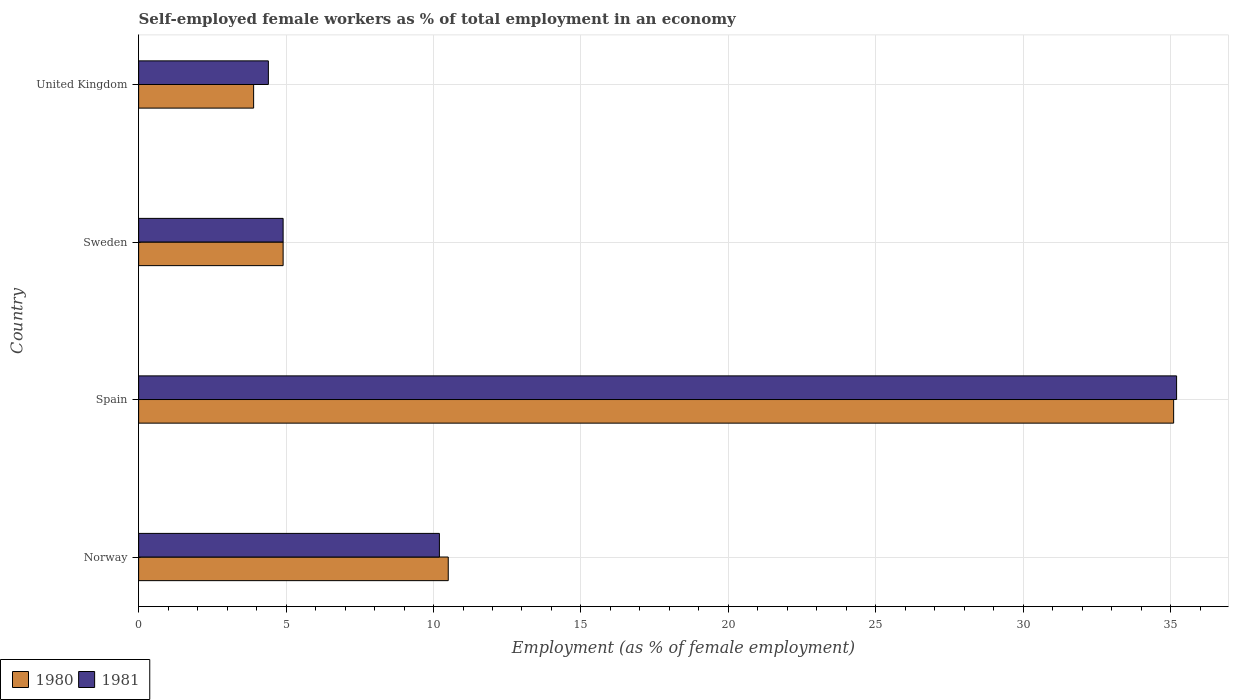How many different coloured bars are there?
Your answer should be compact. 2. How many groups of bars are there?
Ensure brevity in your answer.  4. How many bars are there on the 2nd tick from the top?
Provide a short and direct response. 2. What is the label of the 3rd group of bars from the top?
Offer a terse response. Spain. What is the percentage of self-employed female workers in 1981 in United Kingdom?
Keep it short and to the point. 4.4. Across all countries, what is the maximum percentage of self-employed female workers in 1981?
Offer a terse response. 35.2. Across all countries, what is the minimum percentage of self-employed female workers in 1981?
Offer a terse response. 4.4. In which country was the percentage of self-employed female workers in 1981 minimum?
Ensure brevity in your answer.  United Kingdom. What is the total percentage of self-employed female workers in 1981 in the graph?
Provide a short and direct response. 54.7. What is the difference between the percentage of self-employed female workers in 1980 in Norway and that in Spain?
Your answer should be compact. -24.6. What is the difference between the percentage of self-employed female workers in 1981 in United Kingdom and the percentage of self-employed female workers in 1980 in Norway?
Your answer should be compact. -6.1. What is the average percentage of self-employed female workers in 1981 per country?
Provide a short and direct response. 13.68. What is the difference between the percentage of self-employed female workers in 1980 and percentage of self-employed female workers in 1981 in Sweden?
Keep it short and to the point. 0. What is the ratio of the percentage of self-employed female workers in 1980 in Norway to that in Sweden?
Provide a short and direct response. 2.14. Is the percentage of self-employed female workers in 1980 in Norway less than that in Sweden?
Provide a succinct answer. No. What is the difference between the highest and the second highest percentage of self-employed female workers in 1980?
Provide a succinct answer. 24.6. What is the difference between the highest and the lowest percentage of self-employed female workers in 1980?
Provide a succinct answer. 31.2. How many bars are there?
Give a very brief answer. 8. Are all the bars in the graph horizontal?
Your response must be concise. Yes. How many countries are there in the graph?
Offer a very short reply. 4. What is the difference between two consecutive major ticks on the X-axis?
Offer a terse response. 5. Does the graph contain any zero values?
Offer a terse response. No. How are the legend labels stacked?
Provide a short and direct response. Horizontal. What is the title of the graph?
Make the answer very short. Self-employed female workers as % of total employment in an economy. Does "2002" appear as one of the legend labels in the graph?
Your answer should be compact. No. What is the label or title of the X-axis?
Offer a terse response. Employment (as % of female employment). What is the label or title of the Y-axis?
Your answer should be very brief. Country. What is the Employment (as % of female employment) in 1981 in Norway?
Your answer should be very brief. 10.2. What is the Employment (as % of female employment) in 1980 in Spain?
Keep it short and to the point. 35.1. What is the Employment (as % of female employment) of 1981 in Spain?
Offer a terse response. 35.2. What is the Employment (as % of female employment) of 1980 in Sweden?
Keep it short and to the point. 4.9. What is the Employment (as % of female employment) in 1981 in Sweden?
Keep it short and to the point. 4.9. What is the Employment (as % of female employment) of 1980 in United Kingdom?
Your response must be concise. 3.9. What is the Employment (as % of female employment) of 1981 in United Kingdom?
Offer a terse response. 4.4. Across all countries, what is the maximum Employment (as % of female employment) of 1980?
Provide a short and direct response. 35.1. Across all countries, what is the maximum Employment (as % of female employment) of 1981?
Offer a terse response. 35.2. Across all countries, what is the minimum Employment (as % of female employment) of 1980?
Make the answer very short. 3.9. Across all countries, what is the minimum Employment (as % of female employment) of 1981?
Your response must be concise. 4.4. What is the total Employment (as % of female employment) in 1980 in the graph?
Your response must be concise. 54.4. What is the total Employment (as % of female employment) in 1981 in the graph?
Your response must be concise. 54.7. What is the difference between the Employment (as % of female employment) of 1980 in Norway and that in Spain?
Ensure brevity in your answer.  -24.6. What is the difference between the Employment (as % of female employment) of 1981 in Norway and that in Spain?
Your answer should be compact. -25. What is the difference between the Employment (as % of female employment) in 1980 in Norway and that in Sweden?
Your response must be concise. 5.6. What is the difference between the Employment (as % of female employment) in 1980 in Norway and that in United Kingdom?
Make the answer very short. 6.6. What is the difference between the Employment (as % of female employment) of 1980 in Spain and that in Sweden?
Offer a terse response. 30.2. What is the difference between the Employment (as % of female employment) in 1981 in Spain and that in Sweden?
Keep it short and to the point. 30.3. What is the difference between the Employment (as % of female employment) in 1980 in Spain and that in United Kingdom?
Ensure brevity in your answer.  31.2. What is the difference between the Employment (as % of female employment) of 1981 in Spain and that in United Kingdom?
Keep it short and to the point. 30.8. What is the difference between the Employment (as % of female employment) of 1981 in Sweden and that in United Kingdom?
Your answer should be compact. 0.5. What is the difference between the Employment (as % of female employment) of 1980 in Norway and the Employment (as % of female employment) of 1981 in Spain?
Ensure brevity in your answer.  -24.7. What is the difference between the Employment (as % of female employment) of 1980 in Norway and the Employment (as % of female employment) of 1981 in Sweden?
Give a very brief answer. 5.6. What is the difference between the Employment (as % of female employment) in 1980 in Norway and the Employment (as % of female employment) in 1981 in United Kingdom?
Provide a short and direct response. 6.1. What is the difference between the Employment (as % of female employment) in 1980 in Spain and the Employment (as % of female employment) in 1981 in Sweden?
Your answer should be compact. 30.2. What is the difference between the Employment (as % of female employment) in 1980 in Spain and the Employment (as % of female employment) in 1981 in United Kingdom?
Offer a terse response. 30.7. What is the difference between the Employment (as % of female employment) of 1980 in Sweden and the Employment (as % of female employment) of 1981 in United Kingdom?
Provide a short and direct response. 0.5. What is the average Employment (as % of female employment) of 1980 per country?
Your answer should be very brief. 13.6. What is the average Employment (as % of female employment) in 1981 per country?
Offer a terse response. 13.68. What is the difference between the Employment (as % of female employment) in 1980 and Employment (as % of female employment) in 1981 in Norway?
Your answer should be compact. 0.3. What is the difference between the Employment (as % of female employment) of 1980 and Employment (as % of female employment) of 1981 in Spain?
Provide a succinct answer. -0.1. What is the ratio of the Employment (as % of female employment) of 1980 in Norway to that in Spain?
Your response must be concise. 0.3. What is the ratio of the Employment (as % of female employment) of 1981 in Norway to that in Spain?
Offer a very short reply. 0.29. What is the ratio of the Employment (as % of female employment) of 1980 in Norway to that in Sweden?
Provide a short and direct response. 2.14. What is the ratio of the Employment (as % of female employment) of 1981 in Norway to that in Sweden?
Ensure brevity in your answer.  2.08. What is the ratio of the Employment (as % of female employment) of 1980 in Norway to that in United Kingdom?
Your answer should be very brief. 2.69. What is the ratio of the Employment (as % of female employment) in 1981 in Norway to that in United Kingdom?
Give a very brief answer. 2.32. What is the ratio of the Employment (as % of female employment) of 1980 in Spain to that in Sweden?
Give a very brief answer. 7.16. What is the ratio of the Employment (as % of female employment) of 1981 in Spain to that in Sweden?
Keep it short and to the point. 7.18. What is the ratio of the Employment (as % of female employment) in 1981 in Spain to that in United Kingdom?
Your answer should be very brief. 8. What is the ratio of the Employment (as % of female employment) of 1980 in Sweden to that in United Kingdom?
Give a very brief answer. 1.26. What is the ratio of the Employment (as % of female employment) of 1981 in Sweden to that in United Kingdom?
Provide a succinct answer. 1.11. What is the difference between the highest and the second highest Employment (as % of female employment) in 1980?
Make the answer very short. 24.6. What is the difference between the highest and the lowest Employment (as % of female employment) of 1980?
Your answer should be very brief. 31.2. What is the difference between the highest and the lowest Employment (as % of female employment) in 1981?
Your response must be concise. 30.8. 